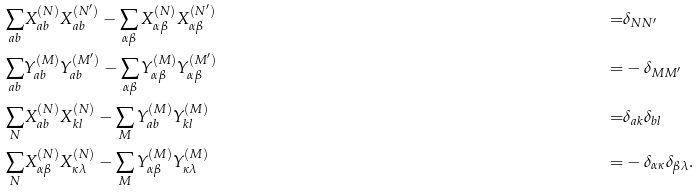Convert formula to latex. <formula><loc_0><loc_0><loc_500><loc_500>\sum _ { a b } & X _ { a b } ^ { ( N ) } X _ { a b } ^ { ( N ^ { \prime } ) } - \sum _ { \alpha \beta } X _ { \alpha \beta } ^ { ( N ) } X _ { \alpha \beta } ^ { ( N ^ { \prime } ) } & = & \delta _ { N N ^ { \prime } } \\ \sum _ { a b } & Y _ { a b } ^ { ( M ) } Y _ { a b } ^ { ( M ^ { \prime } ) } - \sum _ { \alpha \beta } Y _ { \alpha \beta } ^ { ( M ) } Y _ { \alpha \beta } ^ { ( M ^ { \prime } ) } & = & - \delta _ { M M ^ { \prime } } \\ \sum _ { N } & X ^ { ( N ) } _ { a b } X ^ { ( N ) } _ { k l } - \sum _ { M } Y ^ { ( M ) } _ { a b } Y ^ { ( M ) } _ { k l } & = & \delta _ { a k } \delta _ { b l } \\ \sum _ { N } & X ^ { ( N ) } _ { \alpha \beta } X ^ { ( N ) } _ { \kappa \lambda } - \sum _ { M } Y ^ { ( M ) } _ { \alpha \beta } Y ^ { ( M ) } _ { \kappa \lambda } & = & - \delta _ { \alpha \kappa } \delta _ { \beta \lambda } .</formula> 